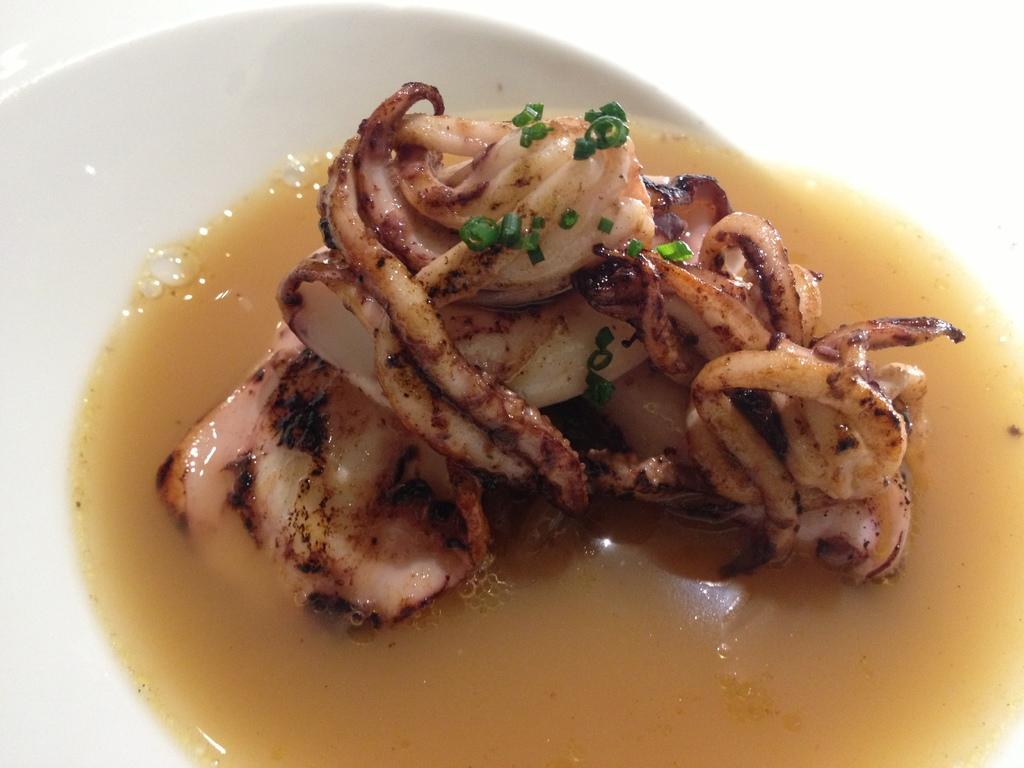What object is present on the plate in the image? There is a food item on the plate in the image. What else can be seen on the plate besides the food item? There is a liquid substance on the plate. What type of owl can be seen in the image? There is no owl present in the image; it only features a plate with a food item and a liquid substance. 